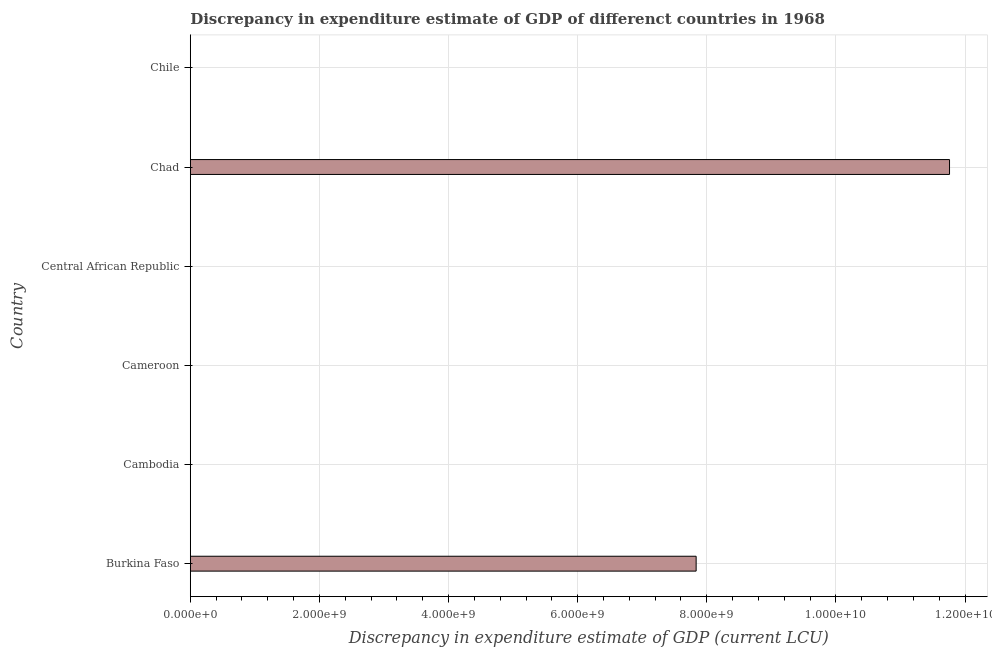What is the title of the graph?
Your answer should be compact. Discrepancy in expenditure estimate of GDP of differenct countries in 1968. What is the label or title of the X-axis?
Make the answer very short. Discrepancy in expenditure estimate of GDP (current LCU). What is the label or title of the Y-axis?
Give a very brief answer. Country. What is the discrepancy in expenditure estimate of gdp in Burkina Faso?
Ensure brevity in your answer.  7.84e+09. Across all countries, what is the maximum discrepancy in expenditure estimate of gdp?
Make the answer very short. 1.18e+1. In which country was the discrepancy in expenditure estimate of gdp maximum?
Ensure brevity in your answer.  Chad. What is the sum of the discrepancy in expenditure estimate of gdp?
Your response must be concise. 1.96e+1. What is the average discrepancy in expenditure estimate of gdp per country?
Your answer should be compact. 3.27e+09. What is the median discrepancy in expenditure estimate of gdp?
Ensure brevity in your answer.  1050. What is the ratio of the discrepancy in expenditure estimate of gdp in Cambodia to that in Central African Republic?
Make the answer very short. 5.00e+07. What is the difference between the highest and the second highest discrepancy in expenditure estimate of gdp?
Provide a succinct answer. 3.92e+09. What is the difference between the highest and the lowest discrepancy in expenditure estimate of gdp?
Provide a succinct answer. 1.18e+1. In how many countries, is the discrepancy in expenditure estimate of gdp greater than the average discrepancy in expenditure estimate of gdp taken over all countries?
Your answer should be compact. 2. Are all the bars in the graph horizontal?
Offer a terse response. Yes. How many countries are there in the graph?
Make the answer very short. 6. Are the values on the major ticks of X-axis written in scientific E-notation?
Keep it short and to the point. Yes. What is the Discrepancy in expenditure estimate of GDP (current LCU) of Burkina Faso?
Your answer should be compact. 7.84e+09. What is the Discrepancy in expenditure estimate of GDP (current LCU) of Cambodia?
Offer a very short reply. 100. What is the Discrepancy in expenditure estimate of GDP (current LCU) of Cameroon?
Make the answer very short. 2000. What is the Discrepancy in expenditure estimate of GDP (current LCU) of Central African Republic?
Your response must be concise. 2e-6. What is the Discrepancy in expenditure estimate of GDP (current LCU) in Chad?
Provide a short and direct response. 1.18e+1. What is the Discrepancy in expenditure estimate of GDP (current LCU) of Chile?
Give a very brief answer. 0. What is the difference between the Discrepancy in expenditure estimate of GDP (current LCU) in Burkina Faso and Cambodia?
Give a very brief answer. 7.84e+09. What is the difference between the Discrepancy in expenditure estimate of GDP (current LCU) in Burkina Faso and Cameroon?
Provide a succinct answer. 7.84e+09. What is the difference between the Discrepancy in expenditure estimate of GDP (current LCU) in Burkina Faso and Central African Republic?
Your answer should be compact. 7.84e+09. What is the difference between the Discrepancy in expenditure estimate of GDP (current LCU) in Burkina Faso and Chad?
Ensure brevity in your answer.  -3.92e+09. What is the difference between the Discrepancy in expenditure estimate of GDP (current LCU) in Cambodia and Cameroon?
Your answer should be very brief. -1900. What is the difference between the Discrepancy in expenditure estimate of GDP (current LCU) in Cambodia and Chad?
Make the answer very short. -1.18e+1. What is the difference between the Discrepancy in expenditure estimate of GDP (current LCU) in Cameroon and Central African Republic?
Provide a short and direct response. 2000. What is the difference between the Discrepancy in expenditure estimate of GDP (current LCU) in Cameroon and Chad?
Provide a short and direct response. -1.18e+1. What is the difference between the Discrepancy in expenditure estimate of GDP (current LCU) in Central African Republic and Chad?
Offer a terse response. -1.18e+1. What is the ratio of the Discrepancy in expenditure estimate of GDP (current LCU) in Burkina Faso to that in Cambodia?
Provide a succinct answer. 7.84e+07. What is the ratio of the Discrepancy in expenditure estimate of GDP (current LCU) in Burkina Faso to that in Cameroon?
Provide a succinct answer. 3.92e+06. What is the ratio of the Discrepancy in expenditure estimate of GDP (current LCU) in Burkina Faso to that in Central African Republic?
Your answer should be compact. 3.92e+15. What is the ratio of the Discrepancy in expenditure estimate of GDP (current LCU) in Burkina Faso to that in Chad?
Your response must be concise. 0.67. What is the ratio of the Discrepancy in expenditure estimate of GDP (current LCU) in Cambodia to that in Cameroon?
Your answer should be very brief. 0.05. What is the ratio of the Discrepancy in expenditure estimate of GDP (current LCU) in Cambodia to that in Central African Republic?
Provide a succinct answer. 5.00e+07. What is the ratio of the Discrepancy in expenditure estimate of GDP (current LCU) in Cambodia to that in Chad?
Your answer should be very brief. 0. What is the ratio of the Discrepancy in expenditure estimate of GDP (current LCU) in Cameroon to that in Central African Republic?
Offer a terse response. 1.00e+09. What is the ratio of the Discrepancy in expenditure estimate of GDP (current LCU) in Cameroon to that in Chad?
Provide a short and direct response. 0. What is the ratio of the Discrepancy in expenditure estimate of GDP (current LCU) in Central African Republic to that in Chad?
Provide a short and direct response. 0. 